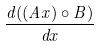Convert formula to latex. <formula><loc_0><loc_0><loc_500><loc_500>\frac { d ( ( A x ) \circ B ) } { d x }</formula> 